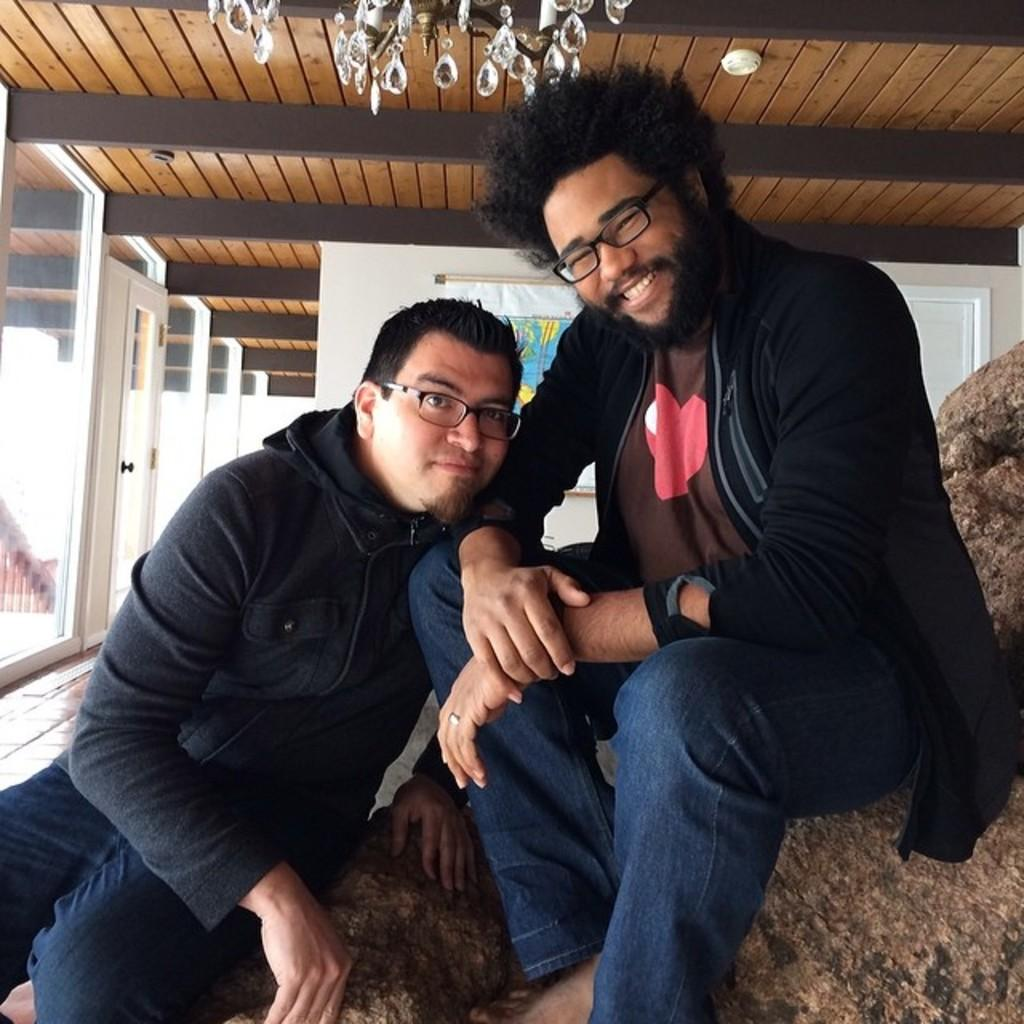How many men are in the image? There are two men in the image. What are the men wearing? Both men are wearing spectacles. What are the men doing in the image? The men are sitting and smiling. What can be seen in the background of the image? There are doors, a banner, and a wall in the background of the image. Can you see the ocean in the background of the image? No, the ocean is not present in the image. What type of silk fabric is draped over the wall in the background? There is no silk fabric present in the image; it only features doors, a banner, and a wall in the background. 